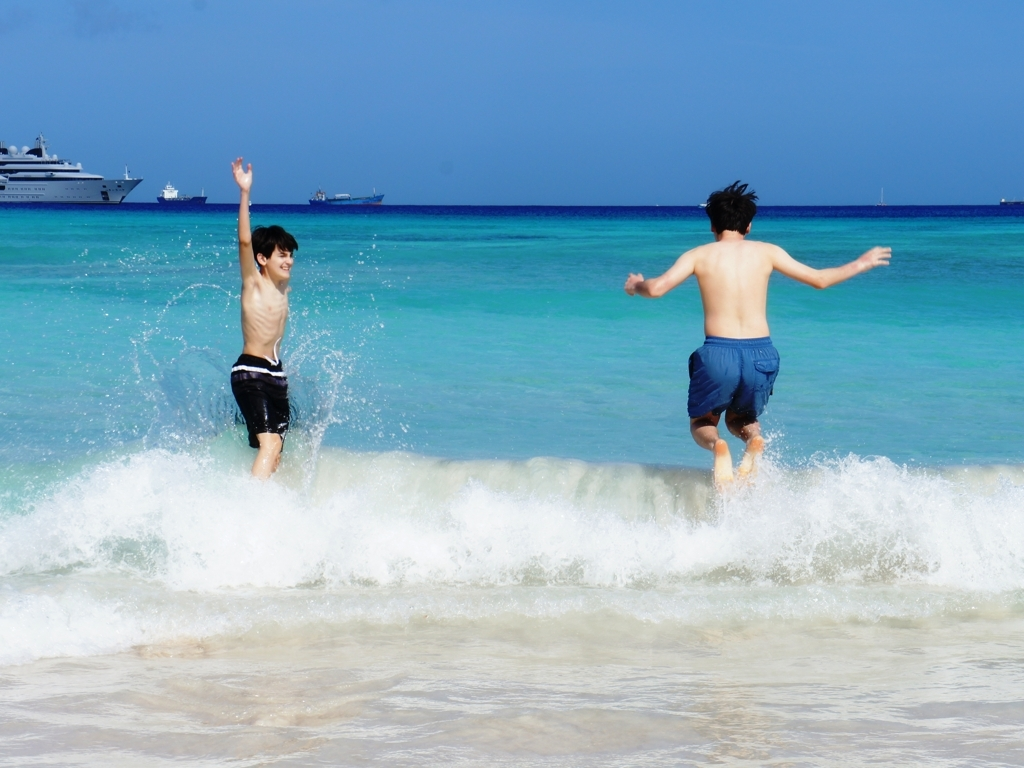What time of day does this image suggest? The brightness of the surroundings and the fact that the sunlight is casting short shadows suggest that this image was taken midday or early afternoon. 